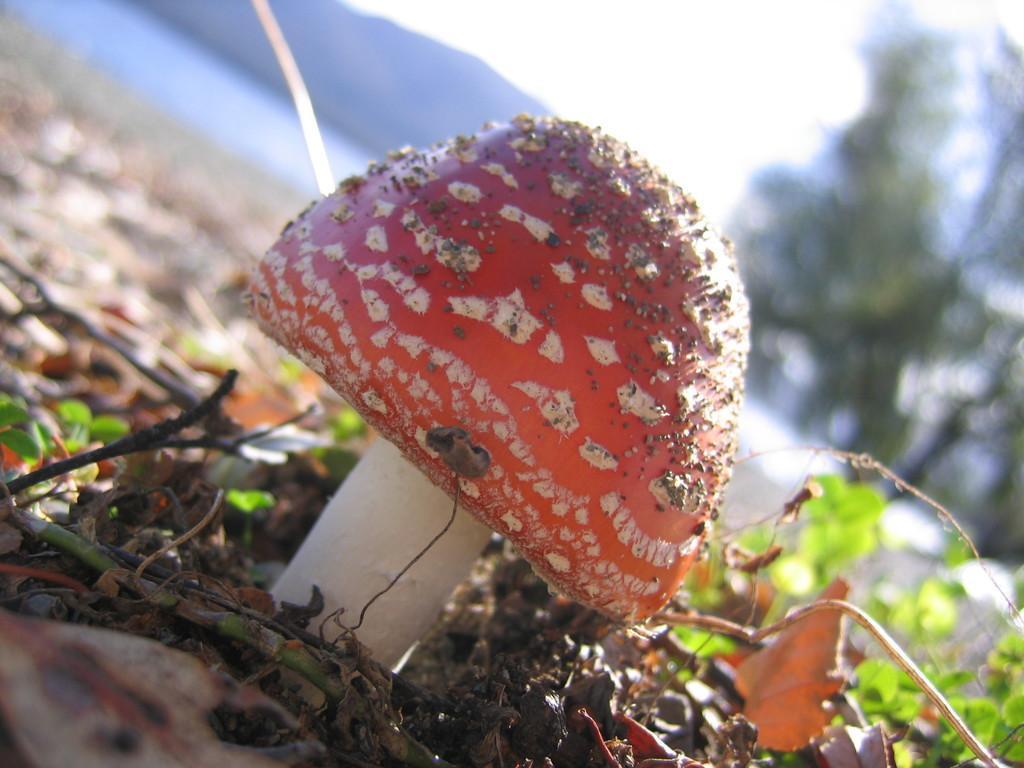In one or two sentences, can you explain what this image depicts? In this image we can see a mushroom, stems, and leaves on the ground. There is a blur background. We can see mountain, trees, and sky. 